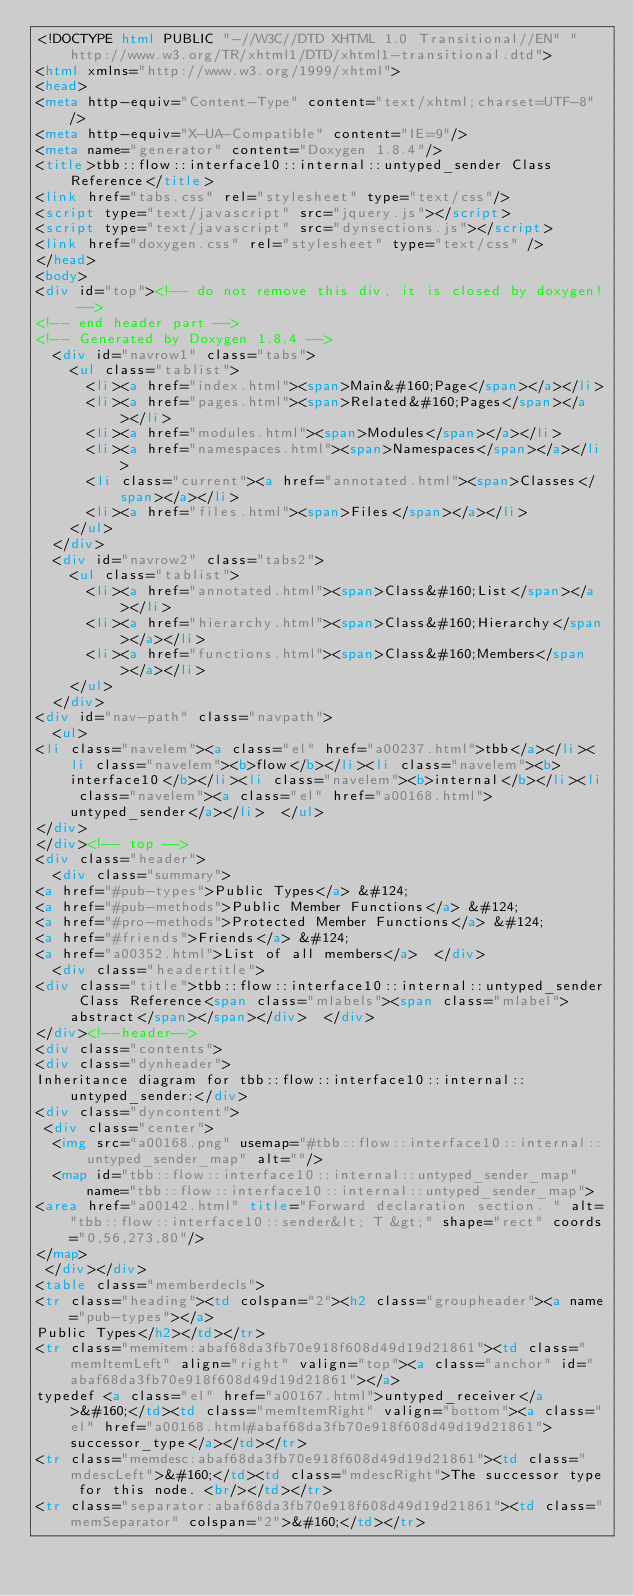Convert code to text. <code><loc_0><loc_0><loc_500><loc_500><_HTML_><!DOCTYPE html PUBLIC "-//W3C//DTD XHTML 1.0 Transitional//EN" "http://www.w3.org/TR/xhtml1/DTD/xhtml1-transitional.dtd">
<html xmlns="http://www.w3.org/1999/xhtml">
<head>
<meta http-equiv="Content-Type" content="text/xhtml;charset=UTF-8"/>
<meta http-equiv="X-UA-Compatible" content="IE=9"/>
<meta name="generator" content="Doxygen 1.8.4"/>
<title>tbb::flow::interface10::internal::untyped_sender Class Reference</title>
<link href="tabs.css" rel="stylesheet" type="text/css"/>
<script type="text/javascript" src="jquery.js"></script>
<script type="text/javascript" src="dynsections.js"></script>
<link href="doxygen.css" rel="stylesheet" type="text/css" />
</head>
<body>
<div id="top"><!-- do not remove this div, it is closed by doxygen! -->
<!-- end header part -->
<!-- Generated by Doxygen 1.8.4 -->
  <div id="navrow1" class="tabs">
    <ul class="tablist">
      <li><a href="index.html"><span>Main&#160;Page</span></a></li>
      <li><a href="pages.html"><span>Related&#160;Pages</span></a></li>
      <li><a href="modules.html"><span>Modules</span></a></li>
      <li><a href="namespaces.html"><span>Namespaces</span></a></li>
      <li class="current"><a href="annotated.html"><span>Classes</span></a></li>
      <li><a href="files.html"><span>Files</span></a></li>
    </ul>
  </div>
  <div id="navrow2" class="tabs2">
    <ul class="tablist">
      <li><a href="annotated.html"><span>Class&#160;List</span></a></li>
      <li><a href="hierarchy.html"><span>Class&#160;Hierarchy</span></a></li>
      <li><a href="functions.html"><span>Class&#160;Members</span></a></li>
    </ul>
  </div>
<div id="nav-path" class="navpath">
  <ul>
<li class="navelem"><a class="el" href="a00237.html">tbb</a></li><li class="navelem"><b>flow</b></li><li class="navelem"><b>interface10</b></li><li class="navelem"><b>internal</b></li><li class="navelem"><a class="el" href="a00168.html">untyped_sender</a></li>  </ul>
</div>
</div><!-- top -->
<div class="header">
  <div class="summary">
<a href="#pub-types">Public Types</a> &#124;
<a href="#pub-methods">Public Member Functions</a> &#124;
<a href="#pro-methods">Protected Member Functions</a> &#124;
<a href="#friends">Friends</a> &#124;
<a href="a00352.html">List of all members</a>  </div>
  <div class="headertitle">
<div class="title">tbb::flow::interface10::internal::untyped_sender Class Reference<span class="mlabels"><span class="mlabel">abstract</span></span></div>  </div>
</div><!--header-->
<div class="contents">
<div class="dynheader">
Inheritance diagram for tbb::flow::interface10::internal::untyped_sender:</div>
<div class="dyncontent">
 <div class="center">
  <img src="a00168.png" usemap="#tbb::flow::interface10::internal::untyped_sender_map" alt=""/>
  <map id="tbb::flow::interface10::internal::untyped_sender_map" name="tbb::flow::interface10::internal::untyped_sender_map">
<area href="a00142.html" title="Forward declaration section. " alt="tbb::flow::interface10::sender&lt; T &gt;" shape="rect" coords="0,56,273,80"/>
</map>
 </div></div>
<table class="memberdecls">
<tr class="heading"><td colspan="2"><h2 class="groupheader"><a name="pub-types"></a>
Public Types</h2></td></tr>
<tr class="memitem:abaf68da3fb70e918f608d49d19d21861"><td class="memItemLeft" align="right" valign="top"><a class="anchor" id="abaf68da3fb70e918f608d49d19d21861"></a>
typedef <a class="el" href="a00167.html">untyped_receiver</a>&#160;</td><td class="memItemRight" valign="bottom"><a class="el" href="a00168.html#abaf68da3fb70e918f608d49d19d21861">successor_type</a></td></tr>
<tr class="memdesc:abaf68da3fb70e918f608d49d19d21861"><td class="mdescLeft">&#160;</td><td class="mdescRight">The successor type for this node. <br/></td></tr>
<tr class="separator:abaf68da3fb70e918f608d49d19d21861"><td class="memSeparator" colspan="2">&#160;</td></tr></code> 